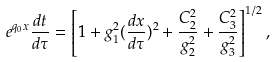<formula> <loc_0><loc_0><loc_500><loc_500>e ^ { q _ { 0 } x } \frac { d t } { d \tau } = \left [ 1 + g _ { 1 } ^ { 2 } ( \frac { d x } { d \tau } ) ^ { 2 } + \frac { C _ { 2 } ^ { 2 } } { g _ { 2 } ^ { 2 } } + \frac { C _ { 3 } ^ { 2 } } { g _ { 3 } ^ { 2 } } \right ] ^ { 1 / 2 } ,</formula> 